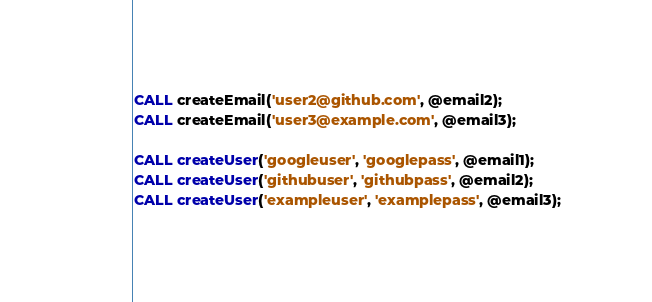Convert code to text. <code><loc_0><loc_0><loc_500><loc_500><_SQL_>CALL createEmail('user2@github.com', @email2);
CALL createEmail('user3@example.com', @email3);

CALL createUser('googleuser', 'googlepass', @email1);
CALL createUser('githubuser', 'githubpass', @email2);
CALL createUser('exampleuser', 'examplepass', @email3);</code> 